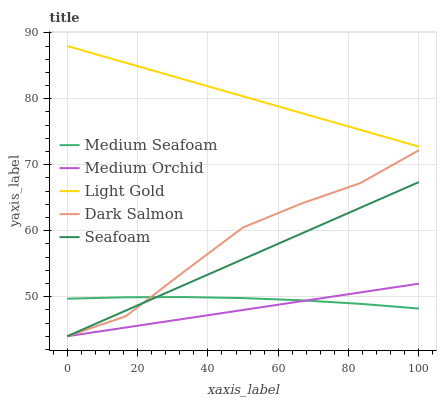Does Medium Orchid have the minimum area under the curve?
Answer yes or no. Yes. Does Light Gold have the maximum area under the curve?
Answer yes or no. Yes. Does Light Gold have the minimum area under the curve?
Answer yes or no. No. Does Medium Orchid have the maximum area under the curve?
Answer yes or no. No. Is Light Gold the smoothest?
Answer yes or no. Yes. Is Dark Salmon the roughest?
Answer yes or no. Yes. Is Medium Orchid the smoothest?
Answer yes or no. No. Is Medium Orchid the roughest?
Answer yes or no. No. Does Seafoam have the lowest value?
Answer yes or no. Yes. Does Light Gold have the lowest value?
Answer yes or no. No. Does Light Gold have the highest value?
Answer yes or no. Yes. Does Medium Orchid have the highest value?
Answer yes or no. No. Is Medium Orchid less than Light Gold?
Answer yes or no. Yes. Is Light Gold greater than Medium Seafoam?
Answer yes or no. Yes. Does Medium Orchid intersect Medium Seafoam?
Answer yes or no. Yes. Is Medium Orchid less than Medium Seafoam?
Answer yes or no. No. Is Medium Orchid greater than Medium Seafoam?
Answer yes or no. No. Does Medium Orchid intersect Light Gold?
Answer yes or no. No. 